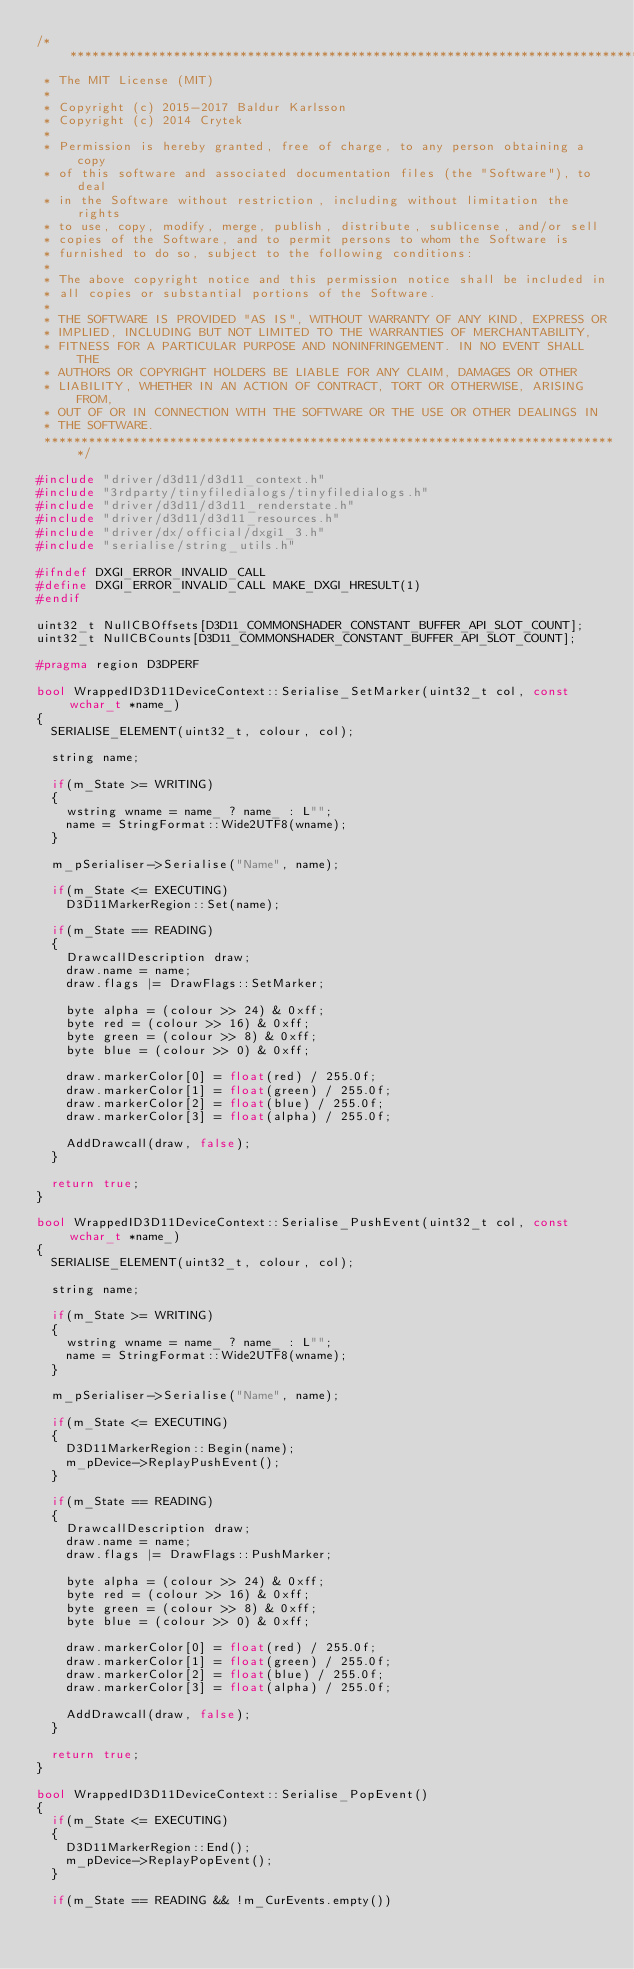Convert code to text. <code><loc_0><loc_0><loc_500><loc_500><_C++_>/******************************************************************************
 * The MIT License (MIT)
 *
 * Copyright (c) 2015-2017 Baldur Karlsson
 * Copyright (c) 2014 Crytek
 *
 * Permission is hereby granted, free of charge, to any person obtaining a copy
 * of this software and associated documentation files (the "Software"), to deal
 * in the Software without restriction, including without limitation the rights
 * to use, copy, modify, merge, publish, distribute, sublicense, and/or sell
 * copies of the Software, and to permit persons to whom the Software is
 * furnished to do so, subject to the following conditions:
 *
 * The above copyright notice and this permission notice shall be included in
 * all copies or substantial portions of the Software.
 *
 * THE SOFTWARE IS PROVIDED "AS IS", WITHOUT WARRANTY OF ANY KIND, EXPRESS OR
 * IMPLIED, INCLUDING BUT NOT LIMITED TO THE WARRANTIES OF MERCHANTABILITY,
 * FITNESS FOR A PARTICULAR PURPOSE AND NONINFRINGEMENT. IN NO EVENT SHALL THE
 * AUTHORS OR COPYRIGHT HOLDERS BE LIABLE FOR ANY CLAIM, DAMAGES OR OTHER
 * LIABILITY, WHETHER IN AN ACTION OF CONTRACT, TORT OR OTHERWISE, ARISING FROM,
 * OUT OF OR IN CONNECTION WITH THE SOFTWARE OR THE USE OR OTHER DEALINGS IN
 * THE SOFTWARE.
 ******************************************************************************/

#include "driver/d3d11/d3d11_context.h"
#include "3rdparty/tinyfiledialogs/tinyfiledialogs.h"
#include "driver/d3d11/d3d11_renderstate.h"
#include "driver/d3d11/d3d11_resources.h"
#include "driver/dx/official/dxgi1_3.h"
#include "serialise/string_utils.h"

#ifndef DXGI_ERROR_INVALID_CALL
#define DXGI_ERROR_INVALID_CALL MAKE_DXGI_HRESULT(1)
#endif

uint32_t NullCBOffsets[D3D11_COMMONSHADER_CONSTANT_BUFFER_API_SLOT_COUNT];
uint32_t NullCBCounts[D3D11_COMMONSHADER_CONSTANT_BUFFER_API_SLOT_COUNT];

#pragma region D3DPERF

bool WrappedID3D11DeviceContext::Serialise_SetMarker(uint32_t col, const wchar_t *name_)
{
  SERIALISE_ELEMENT(uint32_t, colour, col);

  string name;

  if(m_State >= WRITING)
  {
    wstring wname = name_ ? name_ : L"";
    name = StringFormat::Wide2UTF8(wname);
  }

  m_pSerialiser->Serialise("Name", name);

  if(m_State <= EXECUTING)
    D3D11MarkerRegion::Set(name);

  if(m_State == READING)
  {
    DrawcallDescription draw;
    draw.name = name;
    draw.flags |= DrawFlags::SetMarker;

    byte alpha = (colour >> 24) & 0xff;
    byte red = (colour >> 16) & 0xff;
    byte green = (colour >> 8) & 0xff;
    byte blue = (colour >> 0) & 0xff;

    draw.markerColor[0] = float(red) / 255.0f;
    draw.markerColor[1] = float(green) / 255.0f;
    draw.markerColor[2] = float(blue) / 255.0f;
    draw.markerColor[3] = float(alpha) / 255.0f;

    AddDrawcall(draw, false);
  }

  return true;
}

bool WrappedID3D11DeviceContext::Serialise_PushEvent(uint32_t col, const wchar_t *name_)
{
  SERIALISE_ELEMENT(uint32_t, colour, col);

  string name;

  if(m_State >= WRITING)
  {
    wstring wname = name_ ? name_ : L"";
    name = StringFormat::Wide2UTF8(wname);
  }

  m_pSerialiser->Serialise("Name", name);

  if(m_State <= EXECUTING)
  {
    D3D11MarkerRegion::Begin(name);
    m_pDevice->ReplayPushEvent();
  }

  if(m_State == READING)
  {
    DrawcallDescription draw;
    draw.name = name;
    draw.flags |= DrawFlags::PushMarker;

    byte alpha = (colour >> 24) & 0xff;
    byte red = (colour >> 16) & 0xff;
    byte green = (colour >> 8) & 0xff;
    byte blue = (colour >> 0) & 0xff;

    draw.markerColor[0] = float(red) / 255.0f;
    draw.markerColor[1] = float(green) / 255.0f;
    draw.markerColor[2] = float(blue) / 255.0f;
    draw.markerColor[3] = float(alpha) / 255.0f;

    AddDrawcall(draw, false);
  }

  return true;
}

bool WrappedID3D11DeviceContext::Serialise_PopEvent()
{
  if(m_State <= EXECUTING)
  {
    D3D11MarkerRegion::End();
    m_pDevice->ReplayPopEvent();
  }

  if(m_State == READING && !m_CurEvents.empty())</code> 